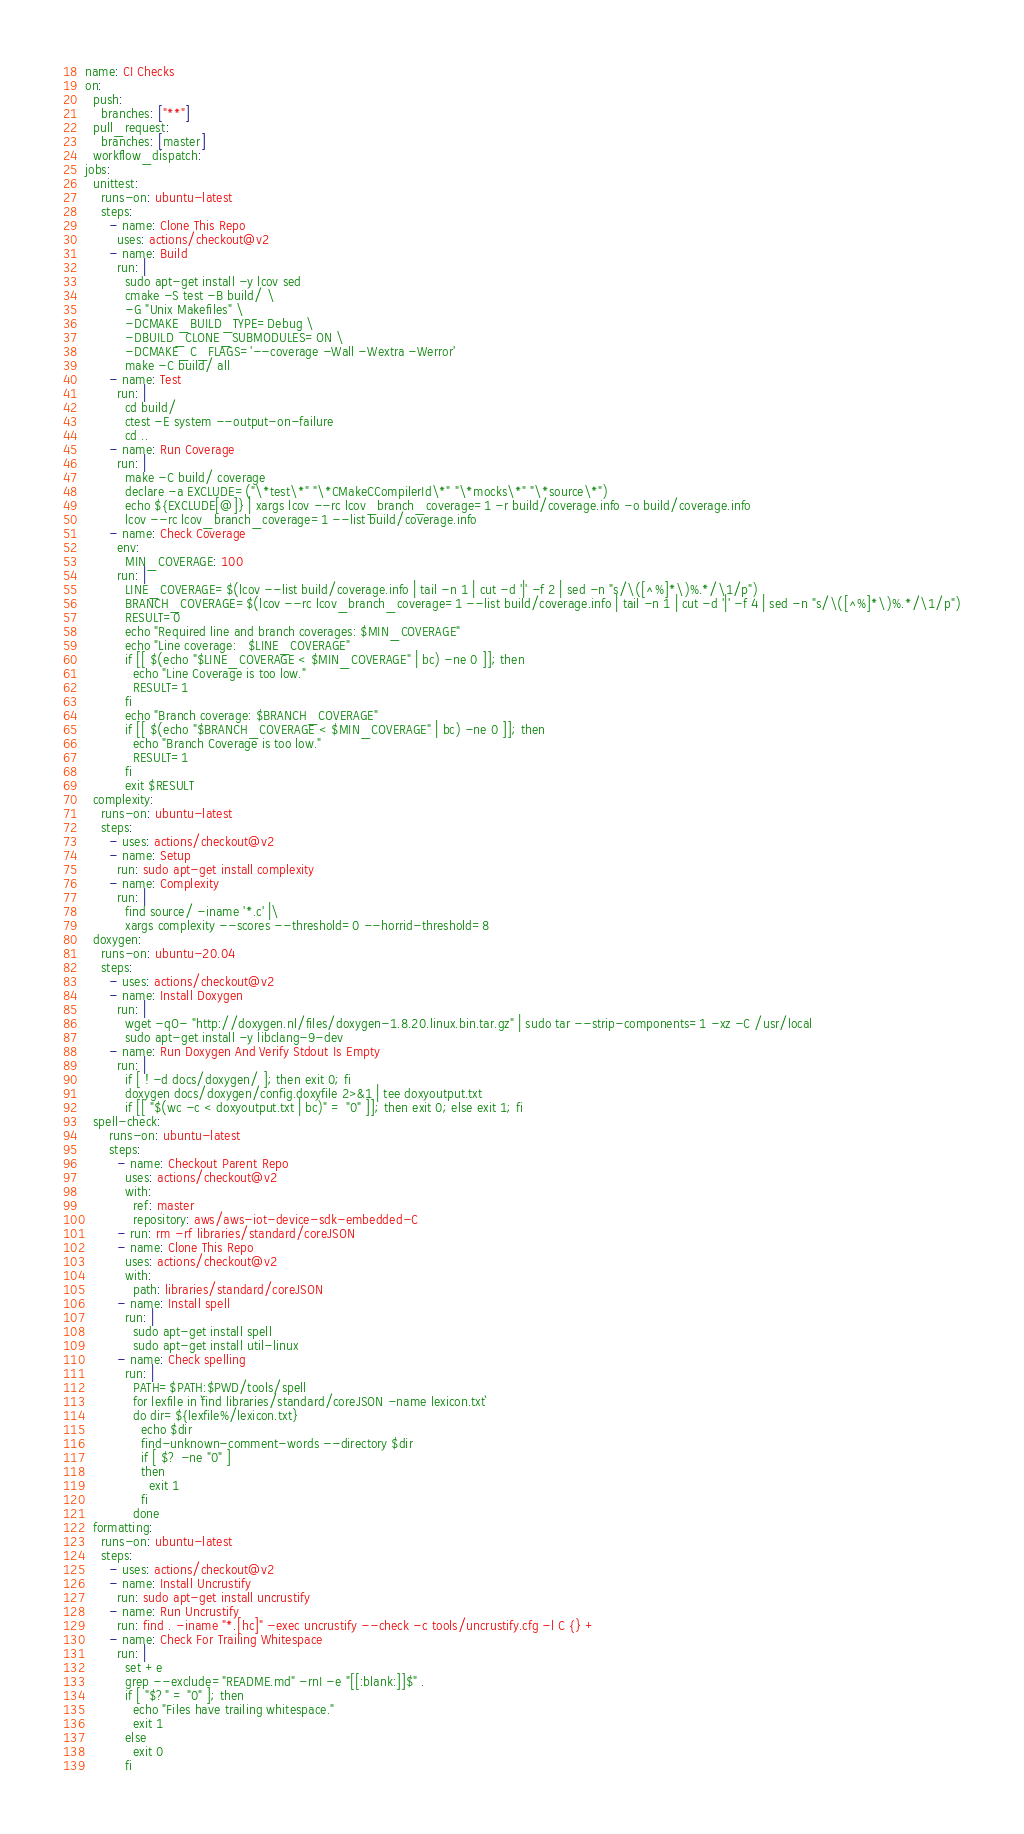Convert code to text. <code><loc_0><loc_0><loc_500><loc_500><_YAML_>name: CI Checks
on:
  push:
    branches: ["**"]
  pull_request:
    branches: [master]
  workflow_dispatch:
jobs:
  unittest:
    runs-on: ubuntu-latest
    steps:
      - name: Clone This Repo
        uses: actions/checkout@v2
      - name: Build
        run: |
          sudo apt-get install -y lcov sed
          cmake -S test -B build/ \
          -G "Unix Makefiles" \
          -DCMAKE_BUILD_TYPE=Debug \
          -DBUILD_CLONE_SUBMODULES=ON \
          -DCMAKE_C_FLAGS='--coverage -Wall -Wextra -Werror'
          make -C build/ all
      - name: Test
        run: |
          cd build/
          ctest -E system --output-on-failure
          cd ..
      - name: Run Coverage
        run: |
          make -C build/ coverage
          declare -a EXCLUDE=("\*test\*" "\*CMakeCCompilerId\*" "\*mocks\*" "\*source\*")
          echo ${EXCLUDE[@]} | xargs lcov --rc lcov_branch_coverage=1 -r build/coverage.info -o build/coverage.info
          lcov --rc lcov_branch_coverage=1 --list build/coverage.info
      - name: Check Coverage
        env:
          MIN_COVERAGE: 100
        run: |
          LINE_COVERAGE=$(lcov --list build/coverage.info | tail -n 1 | cut -d '|' -f 2 | sed -n "s/\([^%]*\)%.*/\1/p")
          BRANCH_COVERAGE=$(lcov --rc lcov_branch_coverage=1 --list build/coverage.info | tail -n 1 | cut -d '|' -f 4 | sed -n "s/\([^%]*\)%.*/\1/p")
          RESULT=0
          echo "Required line and branch coverages: $MIN_COVERAGE"
          echo "Line coverage:   $LINE_COVERAGE"
          if [[ $(echo "$LINE_COVERAGE < $MIN_COVERAGE" | bc) -ne 0 ]]; then
            echo "Line Coverage is too low."
            RESULT=1
          fi
          echo "Branch coverage: $BRANCH_COVERAGE"
          if [[ $(echo "$BRANCH_COVERAGE < $MIN_COVERAGE" | bc) -ne 0 ]]; then
            echo "Branch Coverage is too low."
            RESULT=1
          fi
          exit $RESULT
  complexity:
    runs-on: ubuntu-latest
    steps:
      - uses: actions/checkout@v2
      - name: Setup
        run: sudo apt-get install complexity
      - name: Complexity
        run: |
          find source/ -iname '*.c' |\
          xargs complexity --scores --threshold=0 --horrid-threshold=8
  doxygen:
    runs-on: ubuntu-20.04
    steps:
      - uses: actions/checkout@v2
      - name: Install Doxygen
        run: |
          wget -qO- "http://doxygen.nl/files/doxygen-1.8.20.linux.bin.tar.gz" | sudo tar --strip-components=1 -xz -C /usr/local
          sudo apt-get install -y libclang-9-dev
      - name: Run Doxygen And Verify Stdout Is Empty
        run: |
          if [ ! -d docs/doxygen/ ]; then exit 0; fi
          doxygen docs/doxygen/config.doxyfile 2>&1 | tee doxyoutput.txt
          if [[ "$(wc -c < doxyoutput.txt | bc)" = "0" ]]; then exit 0; else exit 1; fi
  spell-check:
      runs-on: ubuntu-latest
      steps:
        - name: Checkout Parent Repo
          uses: actions/checkout@v2
          with:
            ref: master
            repository: aws/aws-iot-device-sdk-embedded-C
        - run: rm -rf libraries/standard/coreJSON
        - name: Clone This Repo
          uses: actions/checkout@v2
          with:
            path: libraries/standard/coreJSON
        - name: Install spell
          run: |
            sudo apt-get install spell
            sudo apt-get install util-linux
        - name: Check spelling
          run: |
            PATH=$PATH:$PWD/tools/spell
            for lexfile in `find libraries/standard/coreJSON -name lexicon.txt`
            do dir=${lexfile%/lexicon.txt}
              echo $dir
              find-unknown-comment-words --directory $dir
              if [ $? -ne "0" ]
              then
                exit 1
              fi
            done
  formatting:
    runs-on: ubuntu-latest
    steps:
      - uses: actions/checkout@v2
      - name: Install Uncrustify
        run: sudo apt-get install uncrustify
      - name: Run Uncrustify
        run: find . -iname "*.[hc]" -exec uncrustify --check -c tools/uncrustify.cfg -l C {} +
      - name: Check For Trailing Whitespace
        run: |
          set +e
          grep --exclude="README.md" -rnI -e "[[:blank:]]$" .
          if [ "$?" = "0" ]; then
            echo "Files have trailing whitespace."
            exit 1
          else
            exit 0
          fi
</code> 